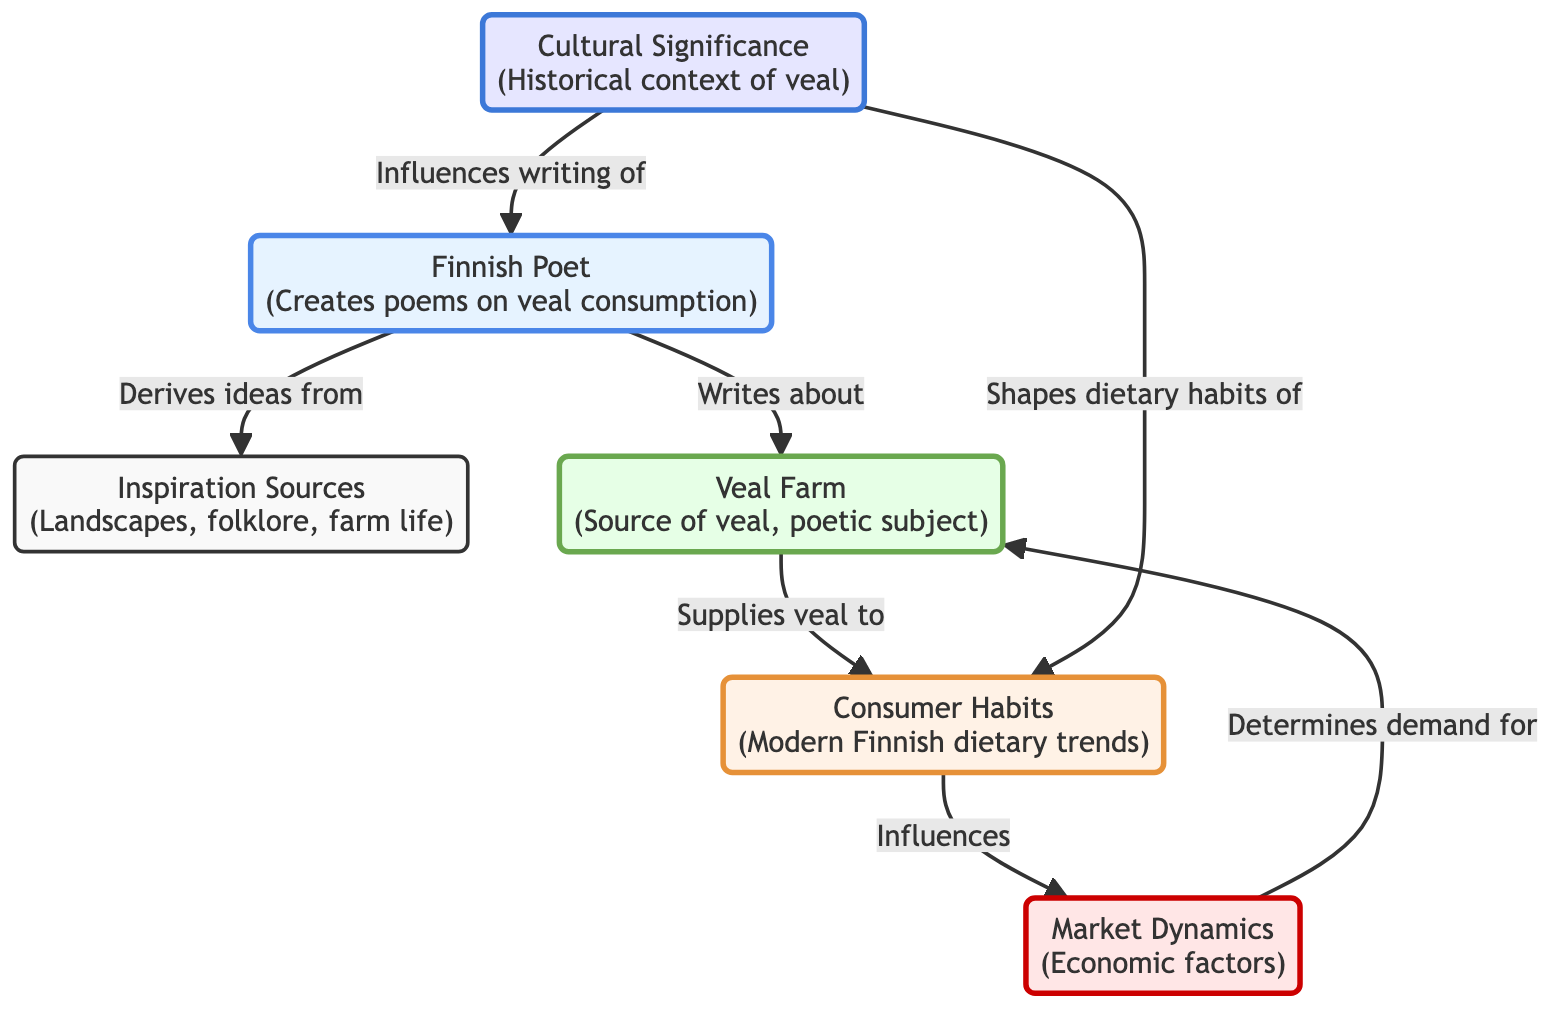What source does the poet derive inspiration from? The diagram specifies that the poet derives inspiration from "Inspiration Sources (Landscapes, folklore, farm life)." This is directly linked to the Poet node, indicating the various elements that influence their creative process.
Answer: Inspiration Sources How many main nodes are present in the diagram? By counting the individual labeled nodes in the diagram, including Poet, Inspiration Sources, Farm, Consumer, Market, and Cultural Significance, there are a total of six distinct nodes that represent different elements of the food chain.
Answer: 6 What influence do consumer habits have in the diagram? The diagram shows a direct relationship where Consumer (Consumer Habits) influences Market (Market Dynamics), indicating that the choices and behaviors of consumers directly affect market activities and trends.
Answer: Influences What role does cultural significance play in the poet's work? Cultural Significance is shown to have a direct influence on the poet's writing by the arrow connecting the two. This suggests that historical and cultural contexts related to veal also shape and inform the poet's creative expressions.
Answer: Influences writing of Which node supplies veal to the consumer? The diagram depicts a clear linkage where Farm (Veal Farm) supplies veal to the Consumer (Consumer Habits), indicating that the farm is the source providing this product to those consuming it.
Answer: Farm What is the relationship between market dynamics and demand? The arrows indicate a flow where Market (Market Dynamics) determines demand for Farm (Veal Farm), suggesting that the market conditions play a crucial role in setting how much veal is needed from the farm.
Answer: Determines demand for What affects dietary habits in the diagram? The diagram illustrates that Cultural Significance shapes dietary habits of the Consumer, establishing a link between cultural understanding and the eating behaviors of individuals, particularly relating to veal consumption.
Answer: Shapes dietary habits of What does the poet write about? The diagram specifically states that the poet writes about the "Veal Farm," identifying this as a primary subject matter in their poetry related to veal consumption.
Answer: Veal Farm 